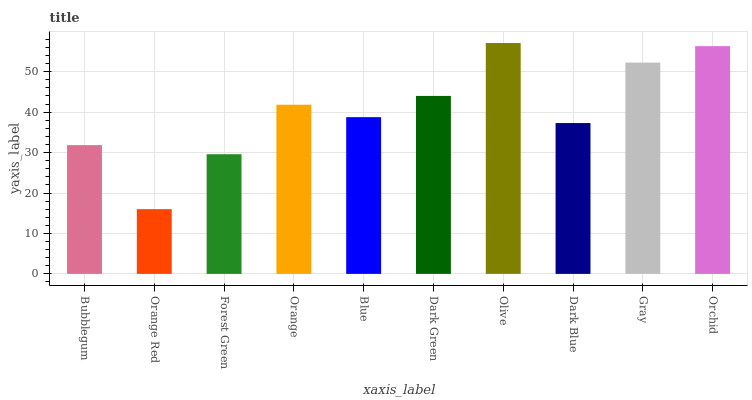Is Orange Red the minimum?
Answer yes or no. Yes. Is Olive the maximum?
Answer yes or no. Yes. Is Forest Green the minimum?
Answer yes or no. No. Is Forest Green the maximum?
Answer yes or no. No. Is Forest Green greater than Orange Red?
Answer yes or no. Yes. Is Orange Red less than Forest Green?
Answer yes or no. Yes. Is Orange Red greater than Forest Green?
Answer yes or no. No. Is Forest Green less than Orange Red?
Answer yes or no. No. Is Orange the high median?
Answer yes or no. Yes. Is Blue the low median?
Answer yes or no. Yes. Is Blue the high median?
Answer yes or no. No. Is Dark Blue the low median?
Answer yes or no. No. 